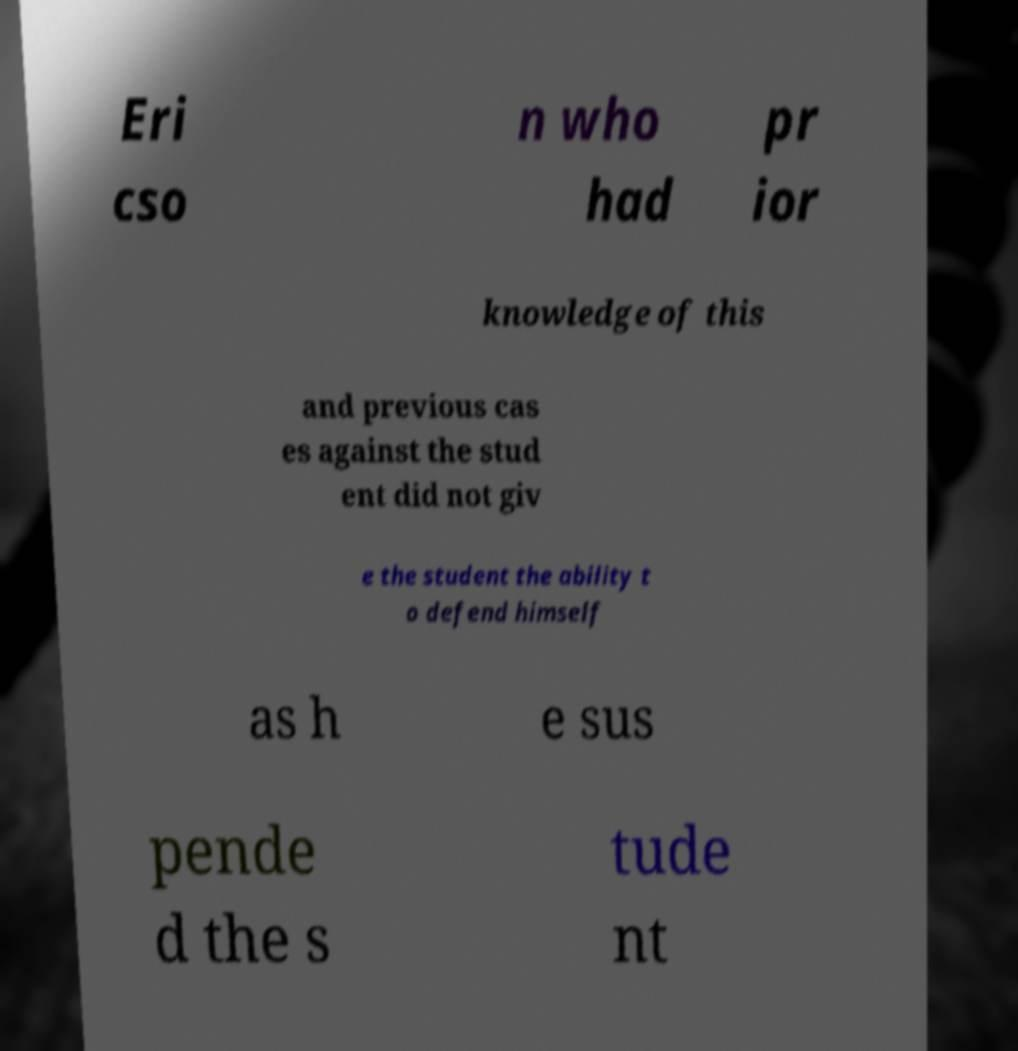Can you accurately transcribe the text from the provided image for me? Eri cso n who had pr ior knowledge of this and previous cas es against the stud ent did not giv e the student the ability t o defend himself as h e sus pende d the s tude nt 